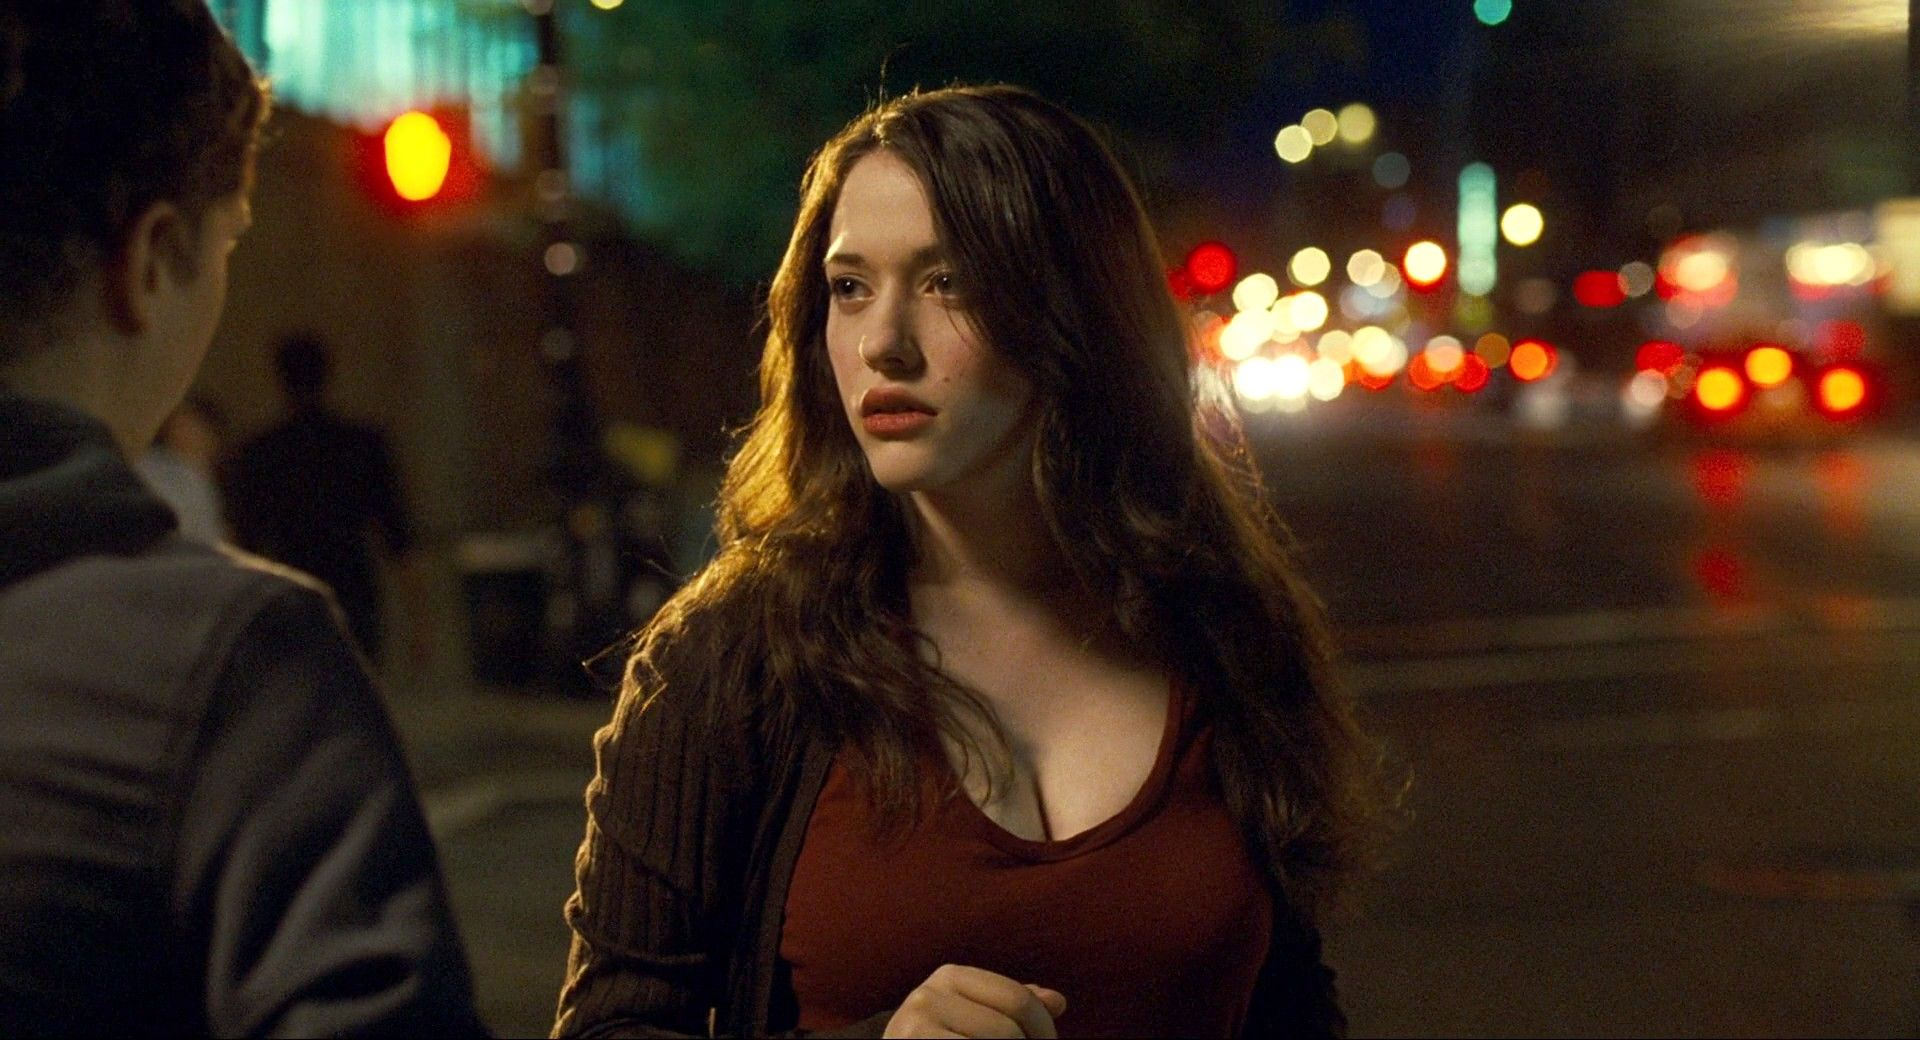Engage in a philosophical discussion about solitude and city life inspired by this image. This image beautifully captures the paradox of solitude amidst the hustle and bustle of city life. It's a profound representation of how one can feel isolated despite being surrounded by people and activity. The woman's thoughtful expression against the vibrant, blurred background suggests an exploration of inner worlds in the midst of external chaos. It raises questions about the nature of human connection, the search for personal meaning in a fast-paced world, and the silent stories each individual carries within them, often unnoticed by those around them. 